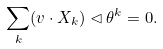<formula> <loc_0><loc_0><loc_500><loc_500>\sum _ { k } ( v \cdot X _ { k } ) \lhd \theta ^ { k } = 0 .</formula> 